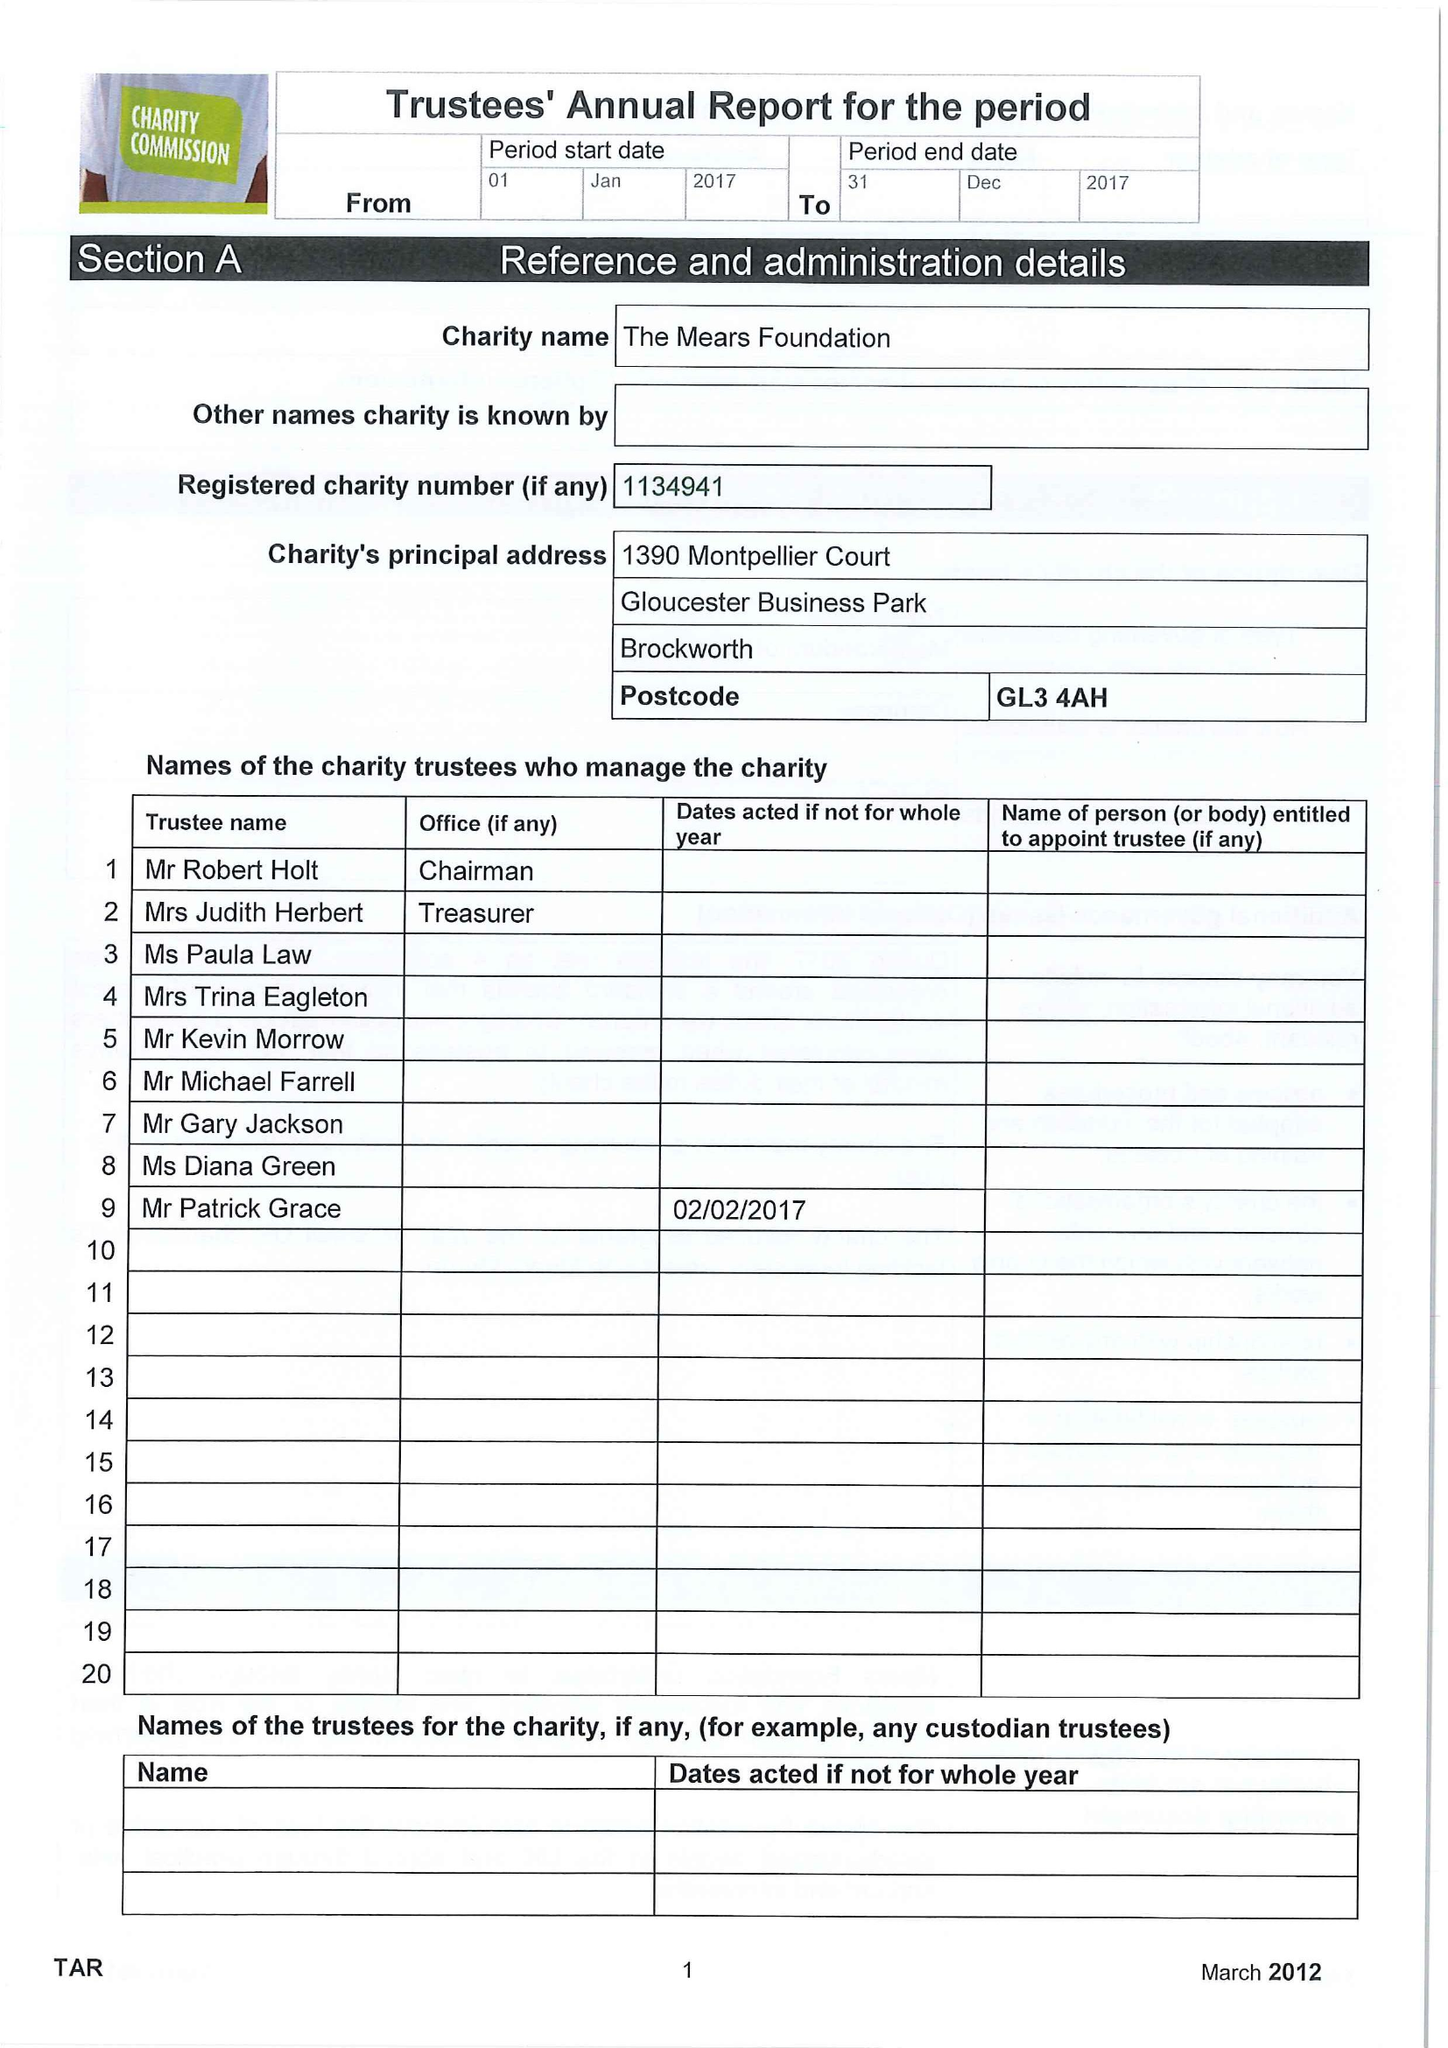What is the value for the income_annually_in_british_pounds?
Answer the question using a single word or phrase. 25192.00 